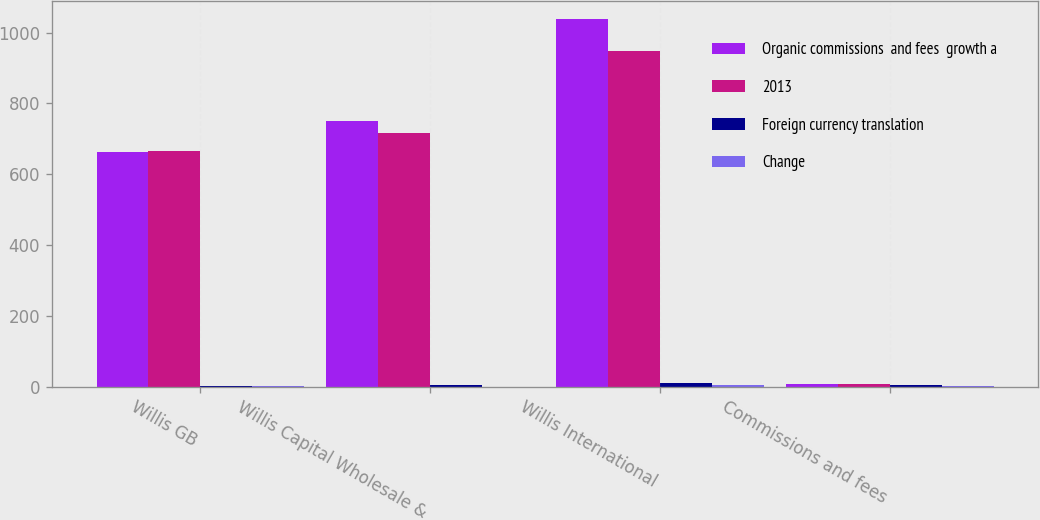<chart> <loc_0><loc_0><loc_500><loc_500><stacked_bar_chart><ecel><fcel>Willis GB<fcel>Willis Capital Wholesale &<fcel>Willis International<fcel>Commissions and fees<nl><fcel>Organic commissions  and fees  growth a<fcel>662<fcel>749<fcel>1038<fcel>7.2<nl><fcel>2013<fcel>665<fcel>716<fcel>948<fcel>7.2<nl><fcel>Foreign currency translation<fcel>0.5<fcel>4.6<fcel>9.5<fcel>3.7<nl><fcel>Change<fcel>1.4<fcel>0.1<fcel>4.9<fcel>0.9<nl></chart> 